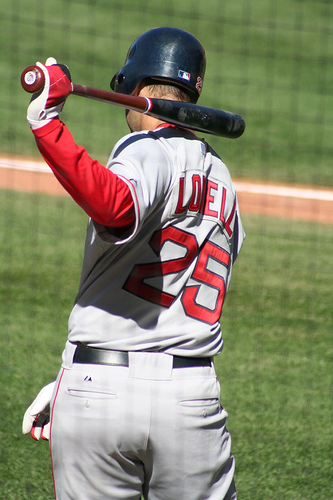Please identify all text content in this image. LOWELL 25 